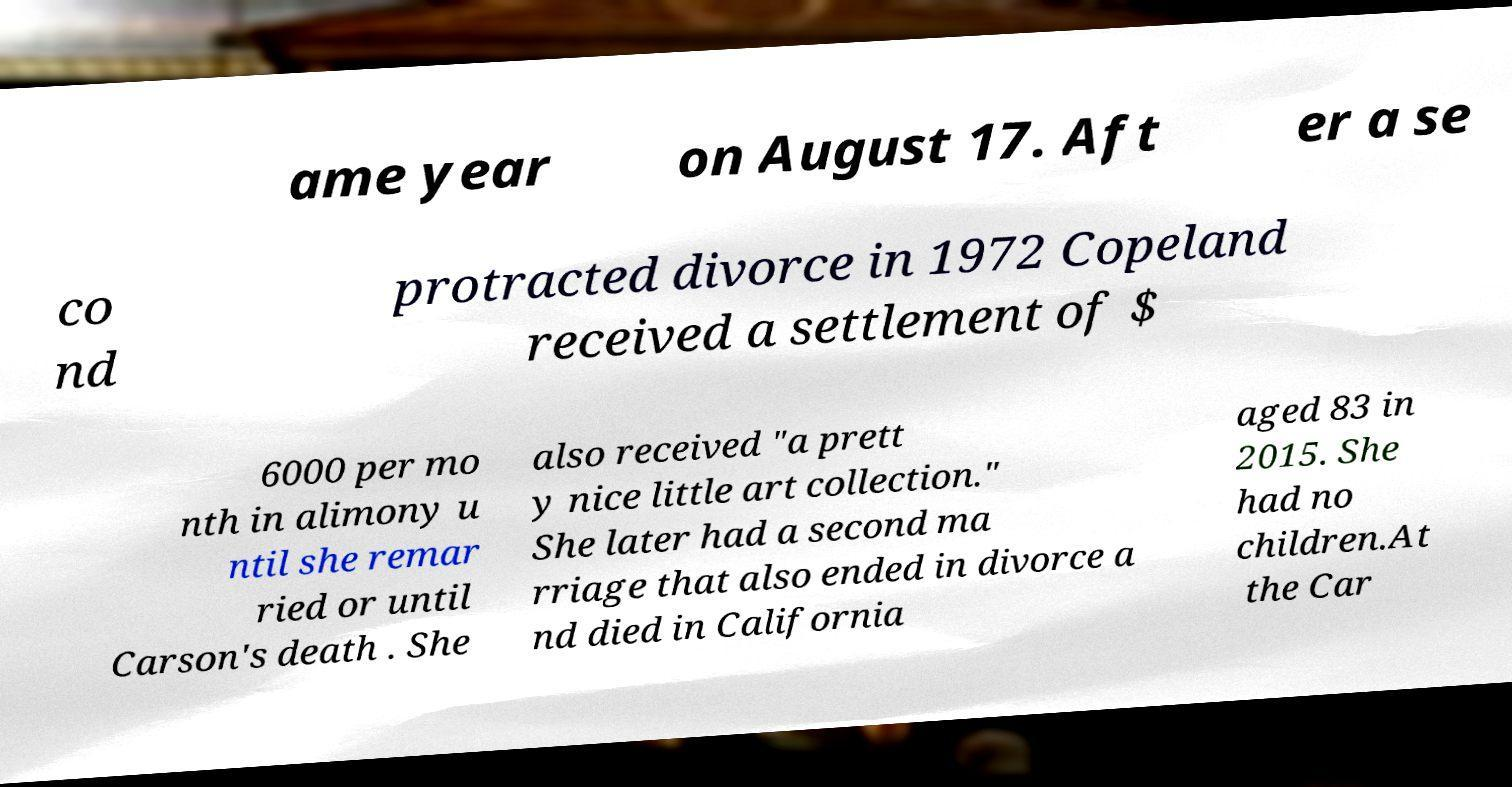I need the written content from this picture converted into text. Can you do that? ame year on August 17. Aft er a se co nd protracted divorce in 1972 Copeland received a settlement of $ 6000 per mo nth in alimony u ntil she remar ried or until Carson's death . She also received "a prett y nice little art collection." She later had a second ma rriage that also ended in divorce a nd died in California aged 83 in 2015. She had no children.At the Car 